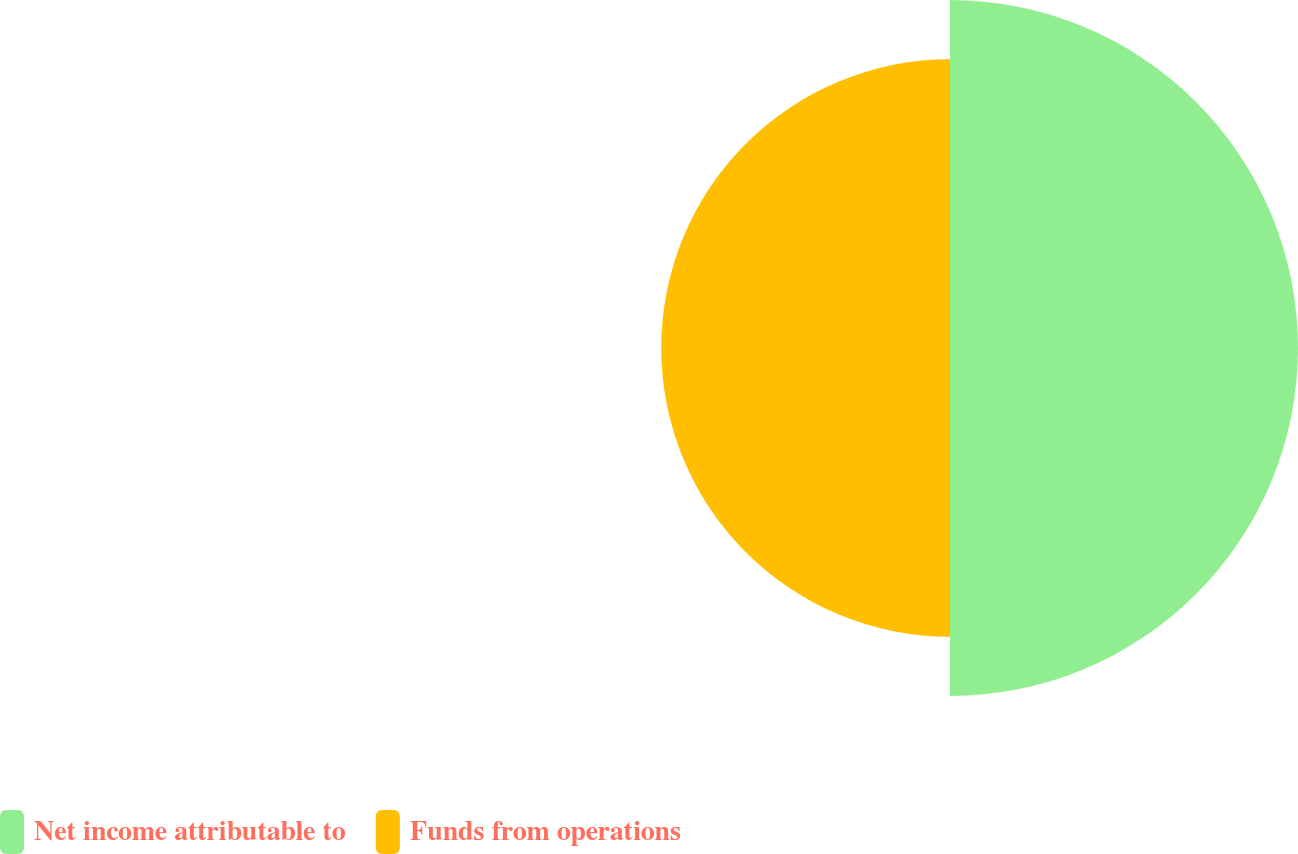Convert chart to OTSL. <chart><loc_0><loc_0><loc_500><loc_500><pie_chart><fcel>Net income attributable to<fcel>Funds from operations<nl><fcel>54.65%<fcel>45.35%<nl></chart> 